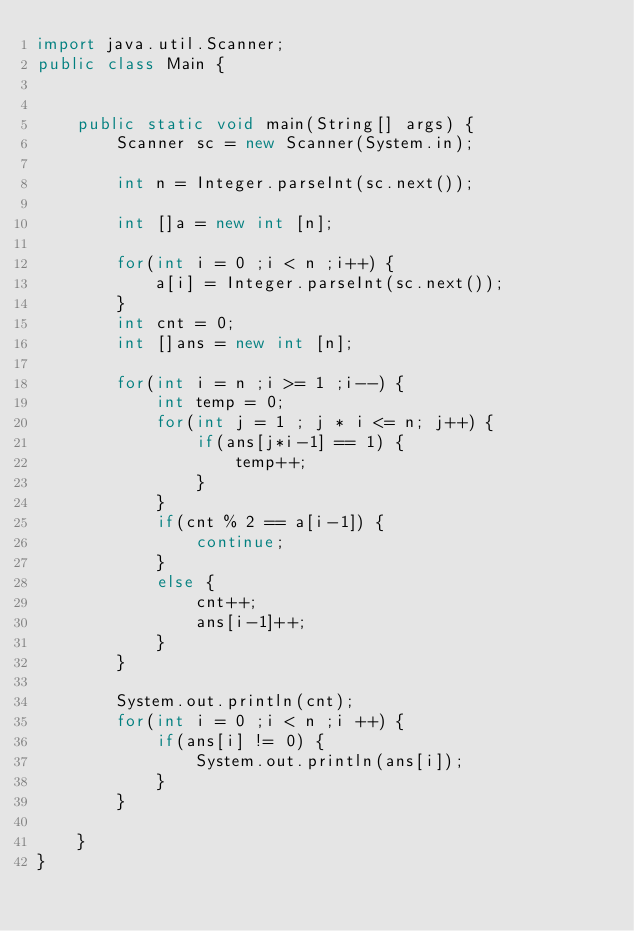Convert code to text. <code><loc_0><loc_0><loc_500><loc_500><_Java_>import java.util.Scanner;
public class Main {
	
	
	public static void main(String[] args) {
		Scanner sc = new Scanner(System.in);
		
		int n = Integer.parseInt(sc.next());
		
		int []a = new int [n];
		
		for(int i = 0 ;i < n ;i++) {
			a[i] = Integer.parseInt(sc.next());
		}
		int cnt = 0;
		int []ans = new int [n];
		
		for(int i = n ;i >= 1 ;i--) {
			int temp = 0;
			for(int j = 1 ; j * i <= n; j++) {
				if(ans[j*i-1] == 1) {
					temp++;
				}
			}
			if(cnt % 2 == a[i-1]) {
				continue;
			}
			else {
				cnt++;
				ans[i-1]++;
			}
		}
		
		System.out.println(cnt);
		for(int i = 0 ;i < n ;i ++) {
			if(ans[i] != 0) {
				System.out.println(ans[i]);
			}
		}
		
	}
}
</code> 